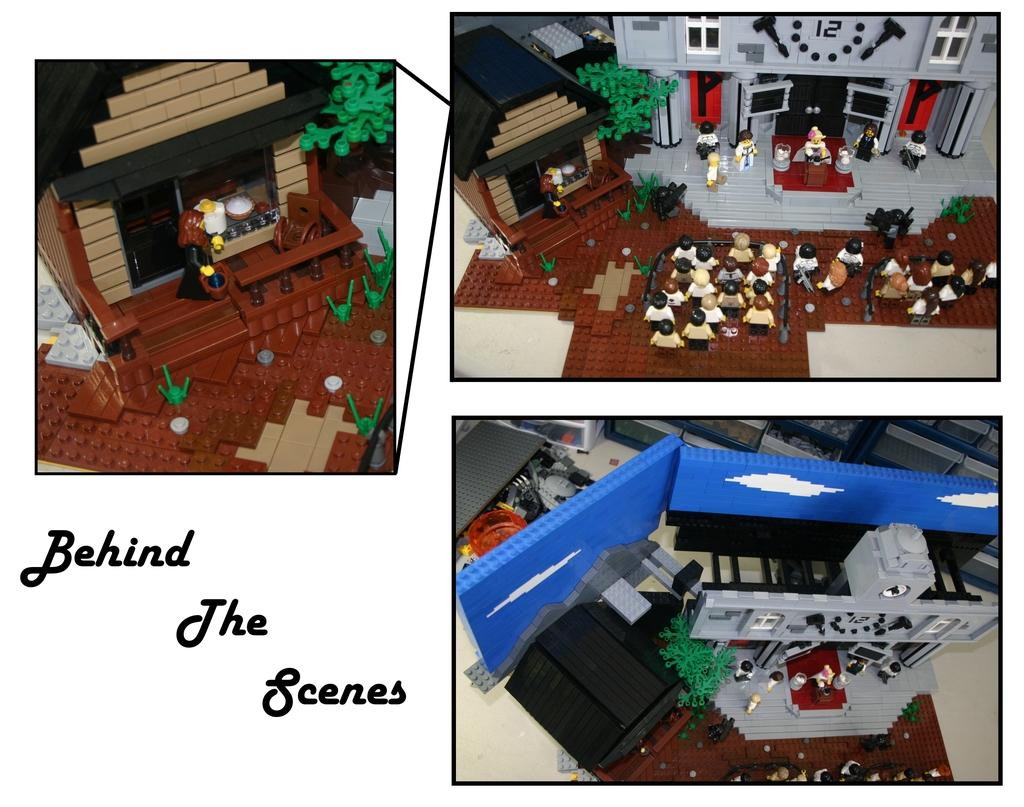How many images are combined in the collage? The image is a collage of three images. What can be seen in one of the images? There are toys in one of the images. What type of structure is present in another image? There is a building in one of the images. What is located beside the building in the image? There is a tree beside the building in one of the images. What type of dwelling is featured in the third image? There is a house in one of the images. How many crows are sitting on the roof of the house in the image? There are no crows present on the roof of the house in the image. What type of sack is being used for the distribution of goods in the image? There is no sack or distribution of goods depicted in the image. 